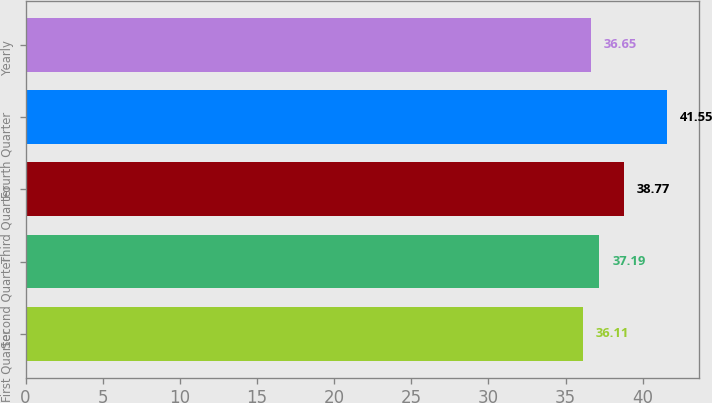Convert chart to OTSL. <chart><loc_0><loc_0><loc_500><loc_500><bar_chart><fcel>First Quarter<fcel>Second Quarter<fcel>Third Quarter<fcel>Fourth Quarter<fcel>Yearly<nl><fcel>36.11<fcel>37.19<fcel>38.77<fcel>41.55<fcel>36.65<nl></chart> 